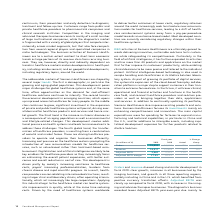According to Siemens Ag's financial document, What was the reason for the increase in the Orders? Orders and revenue showed strong and similar development in fiscal 2019: clear growth; increases in all businesses led by the imaging business, and growth in all three reporting regions, notably including in China and in the U. S. which benefited from positive currency translation effects.. The document states: "Orders and revenue showed strong and similar development in fiscal 2019: clear growth; increases in all businesses led by the imaging business, and gr..." Also, What was the reason for the increase in the Adjusted EBITDA? Based on the financial document, the answer is Adjusted EBITA was clearly up compared to fiscal 2018, with increases in the imaging and advance therapies businesses. The diagnostics business recorded lower Adjusted EBITA year-over-year due mainly to Combined Management Report 13 increases in costs related to its Atellica Solution platform.. Also, How have the markets served by Siemens Healthineers responded in 2019? Based on the financial document, the answer is While demand in the markets served by Siemens Healthineers continued to grow in fiscal 2019, these markets also showed price pressure on new purchases and increased utilization rates for installed systems.. Also, can you calculate: What was the average orders for 2019 and 2018? To answer this question, I need to perform calculations using the financial data. The calculation is: (15,853 + 14,506) / 2, which equals 15179.5 (in millions). This is based on the information: "Orders 15,853 14,506 9 % 7 % Orders 15,853 14,506 9 % 7 %..." The key data points involved are: 14,506, 15,853. Also, can you calculate: What it the increase / (decrease) in revenue from 2018 to 2019? Based on the calculation: 14,517 - 13,425, the result is 1092 (in millions). This is based on the information: "Revenue 14,517 13,425 8 % 6 % Revenue 14,517 13,425 8 % 6 %..." The key data points involved are: 13,425, 14,517. Also, can you calculate: What is the increase / (decrease) in the Adjusted EBITDA margin from 2018 to 2019? Based on the calculation: 17.0% - 16.5%, the result is 0.5 (percentage). This is based on the information: "Adjusted EBITA margin 17.0 % 16.5 % Adjusted EBITA margin 17.0 % 16.5 %..." The key data points involved are: 16.5, 17.0. 